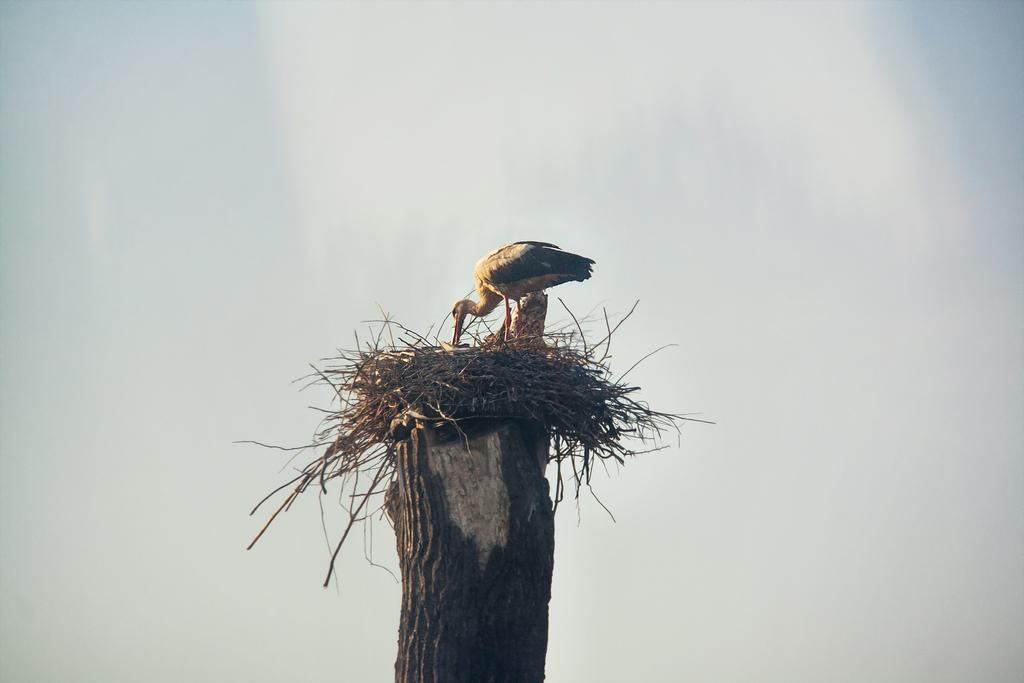What type of animal can be seen in the image? There is a bird in the image. What structure is associated with the bird in the image? There is a nest in the image. What material is the nest resting on? The nest is on a wooden object. What can be seen in the background of the image? The sky is visible in the background of the image. What type of engine is powering the bird in the image? There is no engine present in the image, as birds do not require engines to fly. 